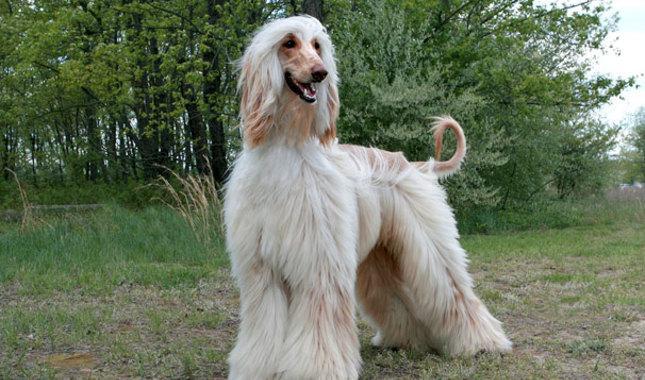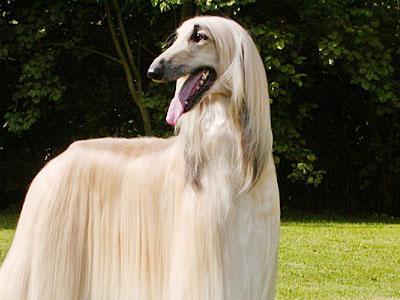The first image is the image on the left, the second image is the image on the right. Evaluate the accuracy of this statement regarding the images: "At least one dog is sitting upright in the grass.". Is it true? Answer yes or no. No. The first image is the image on the left, the second image is the image on the right. For the images displayed, is the sentence "At least one image shows a hound on all fours on the grassy ground." factually correct? Answer yes or no. Yes. 